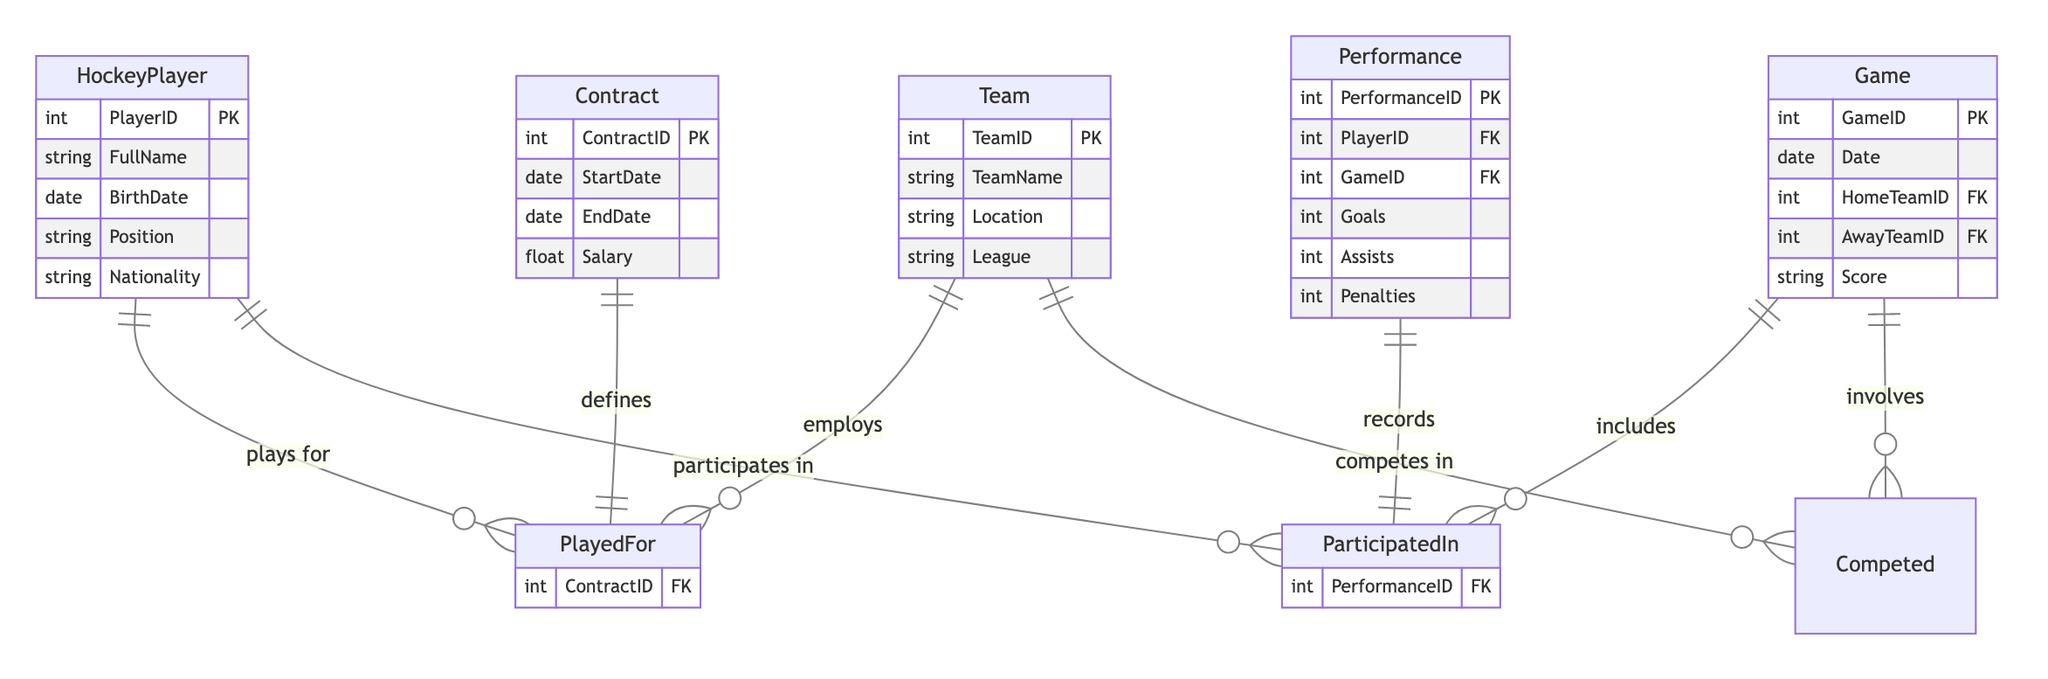What is the primary entity that represents a player? The diagram shows the entity named "HockeyPlayer," which is the primary representation of a player in the context of this Entity Relationship Diagram.
Answer: HockeyPlayer How many attributes does the Team entity have? In the diagram, the Team entity is defined with four attributes: TeamID, TeamName, Location, and League. Counting these gives us the answer.
Answer: 4 What relationship exists between HockeyPlayer and Team? The diagram indicates a "PlayedFor" relationship between the HockeyPlayer and Team entities, denoting the association that players have with the teams they play for.
Answer: PlayedFor Which entity records the performance of a player in a game? The "Performance" entity is responsible for recording the details of a player's performance in each game, including statistics like goals and assists.
Answer: Performance Can a player participate in multiple games? The "ParticipatedIn" relationship between HockeyPlayer and Game is defined as many-to-many, meaning a single player can participate in multiple games, and multiple players can participate in the same game.
Answer: Yes How many relationships connect the Game entity to other entities? Analyzing the diagram, the Game entity is connected through two relationships: "ParticipatedIn" with HockeyPlayer and "Competed" with Team, resulting in two connections.
Answer: 2 What is the connection type between the Team and Game entities? The connection type established between the Team and Game entities is a many-to-many relationship called "Competed," which indicates that multiple teams can compete in multiple games.
Answer: ManyToMany What does the Contract entity define in the relationship with HockeyPlayer? The Contract entity is critical in defining the relationship between HockeyPlayer and Team by linking the contracts under which players play for teams.
Answer: Defines 